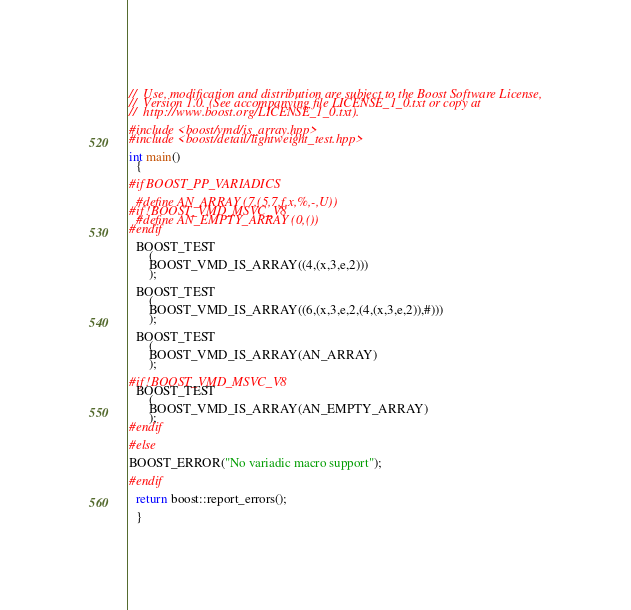<code> <loc_0><loc_0><loc_500><loc_500><_C++_>//  Use, modification and distribution are subject to the Boost Software License,
//  Version 1.0. (See accompanying file LICENSE_1_0.txt or copy at
//  http://www.boost.org/LICENSE_1_0.txt).

#include <boost/vmd/is_array.hpp>
#include <boost/detail/lightweight_test.hpp>

int main()
  {
  
#if BOOST_PP_VARIADICS

  #define AN_ARRAY (7,(5,7,f,x,%,-,U))
#if !BOOST_VMD_MSVC_V8  
  #define AN_EMPTY_ARRAY (0,())
#endif
  
  BOOST_TEST
      (
      BOOST_VMD_IS_ARRAY((4,(x,3,e,2)))
      );
      
  BOOST_TEST
      (
      BOOST_VMD_IS_ARRAY((6,(x,3,e,2,(4,(x,3,e,2)),#)))
      );
      
  BOOST_TEST
      (
      BOOST_VMD_IS_ARRAY(AN_ARRAY)
      );
    
#if !BOOST_VMD_MSVC_V8
  BOOST_TEST
      (
      BOOST_VMD_IS_ARRAY(AN_EMPTY_ARRAY)
      );
#endif
    
#else

BOOST_ERROR("No variadic macro support");
  
#endif

  return boost::report_errors();
  
  }
</code> 